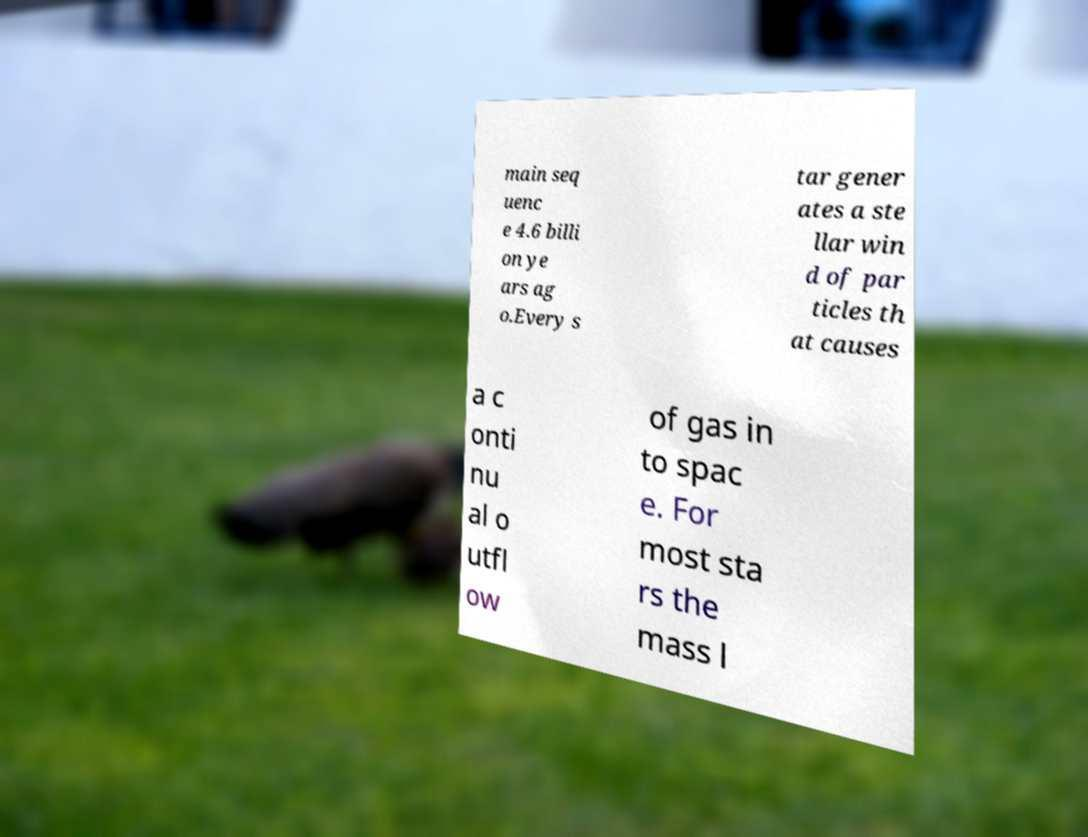Please identify and transcribe the text found in this image. main seq uenc e 4.6 billi on ye ars ag o.Every s tar gener ates a ste llar win d of par ticles th at causes a c onti nu al o utfl ow of gas in to spac e. For most sta rs the mass l 